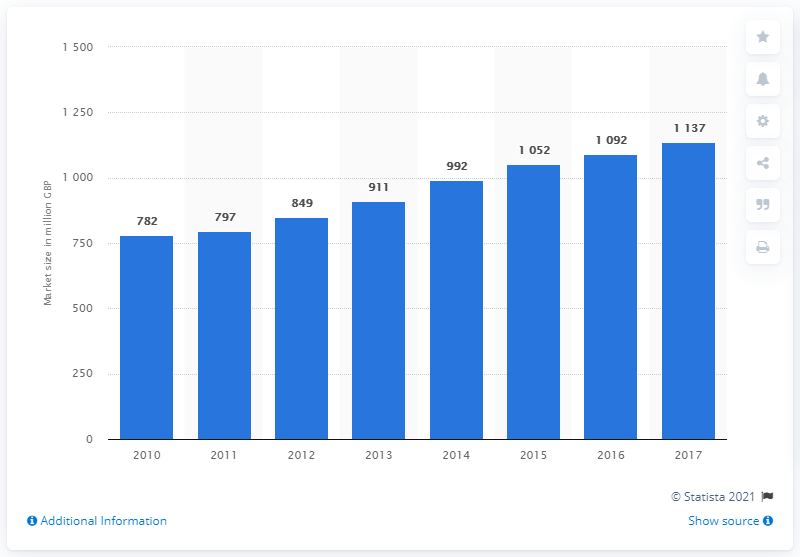Highlight a few significant elements in this photo. In 2010, the cyber security sector in the UK was predicted to be the largest in the country. 